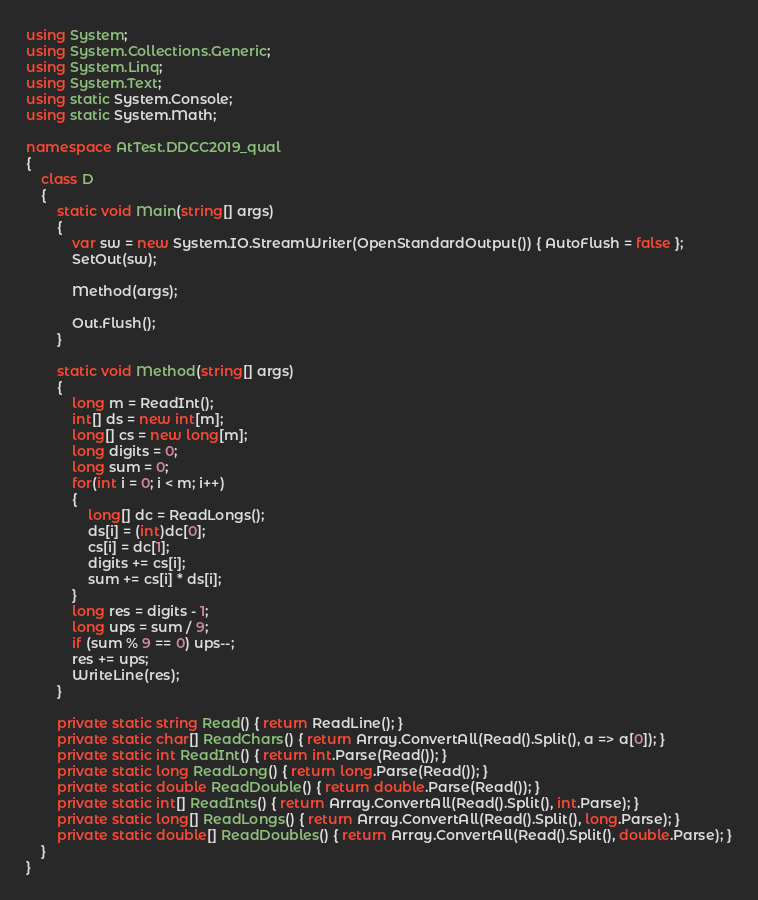Convert code to text. <code><loc_0><loc_0><loc_500><loc_500><_C#_>using System;
using System.Collections.Generic;
using System.Linq;
using System.Text;
using static System.Console;
using static System.Math;

namespace AtTest.DDCC2019_qual
{
    class D
    {
        static void Main(string[] args)
        {
            var sw = new System.IO.StreamWriter(OpenStandardOutput()) { AutoFlush = false };
            SetOut(sw);

            Method(args);

            Out.Flush();
        }

        static void Method(string[] args)
        {
            long m = ReadInt();
            int[] ds = new int[m];
            long[] cs = new long[m];
            long digits = 0;
            long sum = 0;
            for(int i = 0; i < m; i++)
            {
                long[] dc = ReadLongs();
                ds[i] = (int)dc[0];
                cs[i] = dc[1];
                digits += cs[i];
                sum += cs[i] * ds[i];
            }
            long res = digits - 1;
            long ups = sum / 9;
            if (sum % 9 == 0) ups--;
            res += ups;
            WriteLine(res);
        }

        private static string Read() { return ReadLine(); }
        private static char[] ReadChars() { return Array.ConvertAll(Read().Split(), a => a[0]); }
        private static int ReadInt() { return int.Parse(Read()); }
        private static long ReadLong() { return long.Parse(Read()); }
        private static double ReadDouble() { return double.Parse(Read()); }
        private static int[] ReadInts() { return Array.ConvertAll(Read().Split(), int.Parse); }
        private static long[] ReadLongs() { return Array.ConvertAll(Read().Split(), long.Parse); }
        private static double[] ReadDoubles() { return Array.ConvertAll(Read().Split(), double.Parse); }
    }
}
</code> 